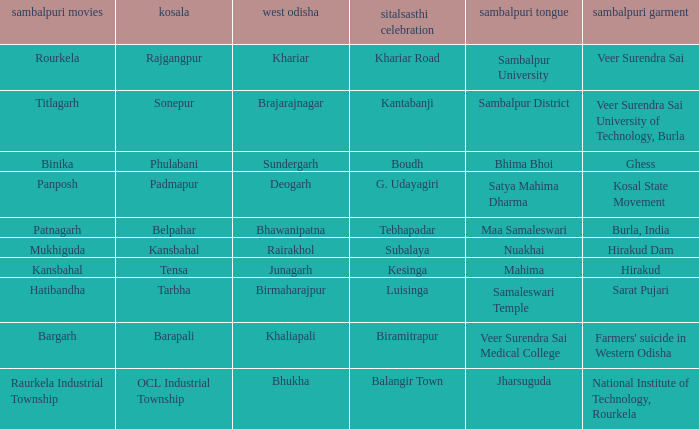What is the sambalpuri saree with a samaleswari temple as sambalpuri language? Sarat Pujari. 